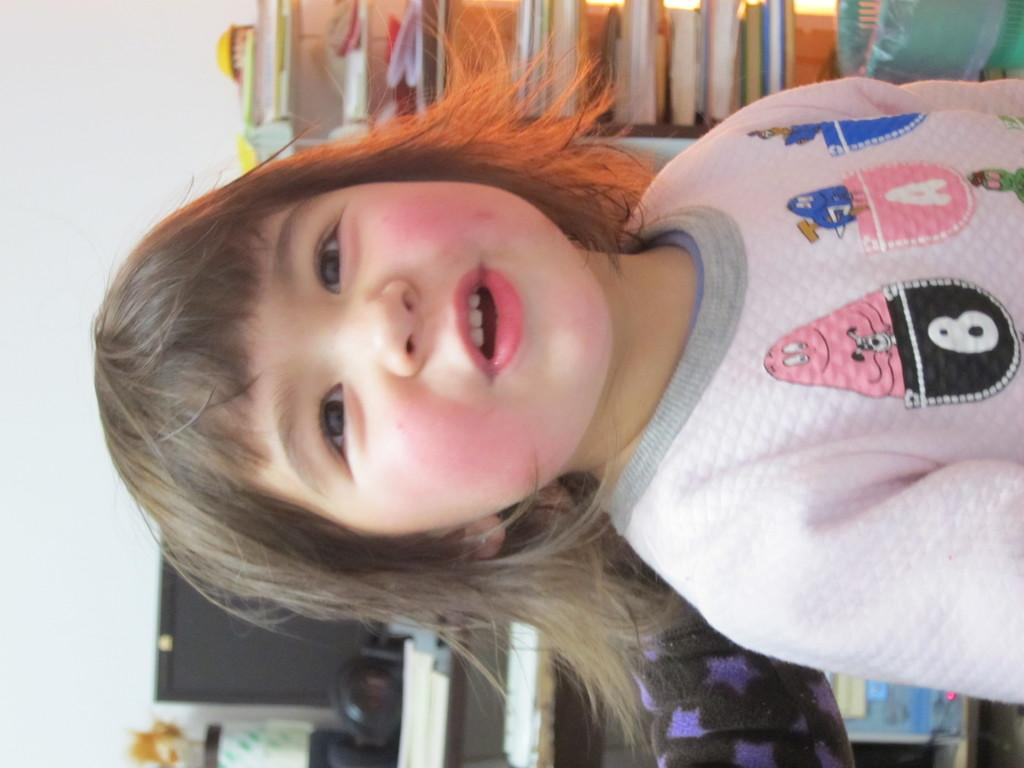Who is the main subject in the foreground of the image? There is a girl in the foreground of the image. What can be seen in the background of the image? There are books in a shelf, a system on a table, a wall, a flower vase, and other objects visible in the background of the image. What type of setting is suggested by the presence of these objects? The image is likely taken in a room. What type of income can be seen in the image? There is no income visible in the image; it features a girl in the foreground and various objects in the background. Is the girl wearing a veil in the image? There is no veil visible on the girl in the image. 